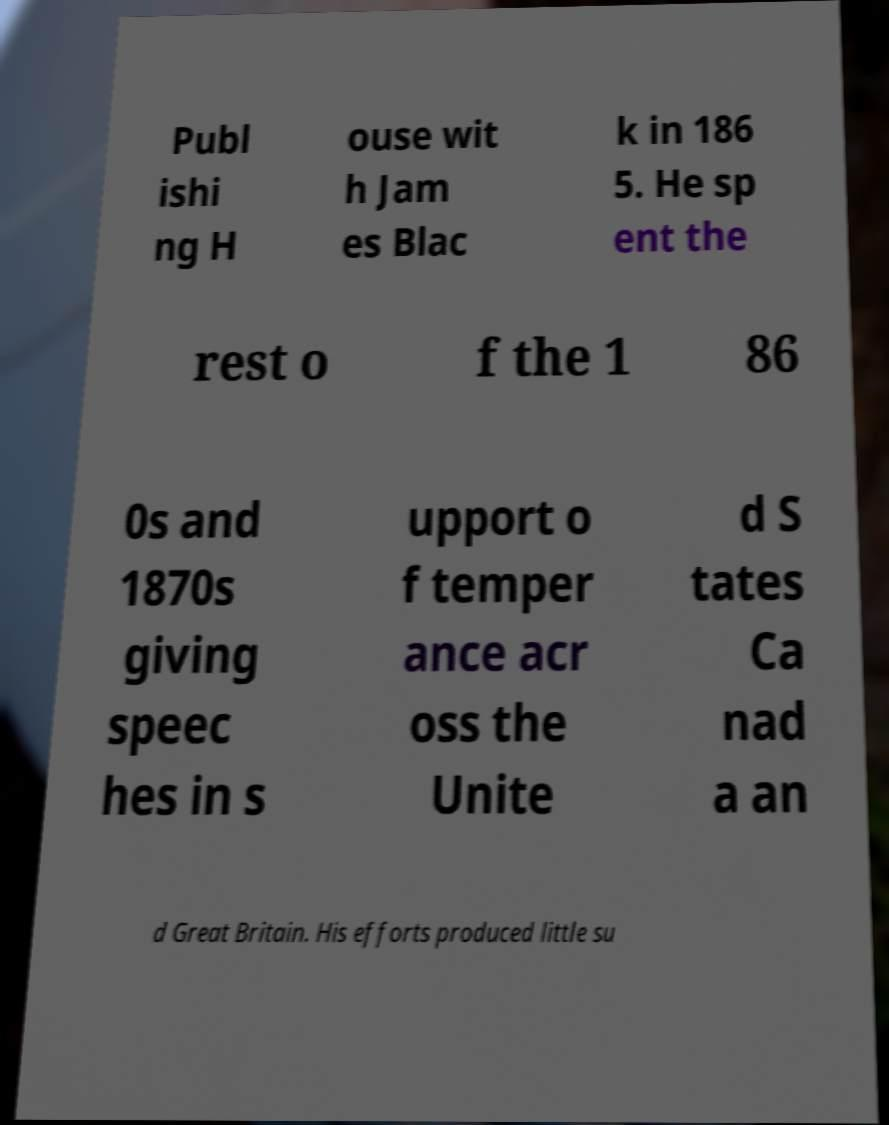I need the written content from this picture converted into text. Can you do that? Publ ishi ng H ouse wit h Jam es Blac k in 186 5. He sp ent the rest o f the 1 86 0s and 1870s giving speec hes in s upport o f temper ance acr oss the Unite d S tates Ca nad a an d Great Britain. His efforts produced little su 